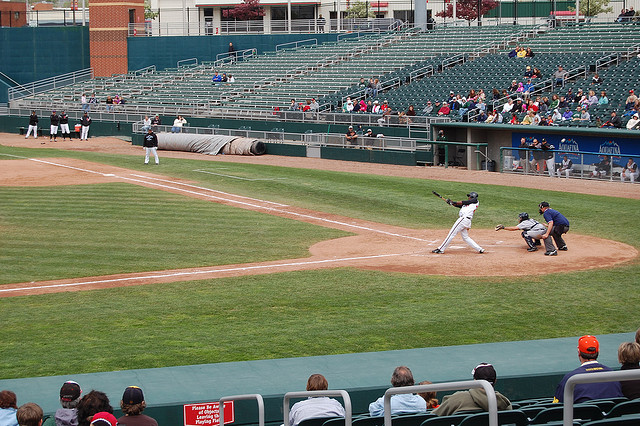What is happening in the image right now? The image shows a live baseball game in progress. A batter is at the plate, apparently just having swung at a pitch. The catcher and the umpire are positioned behind the home plate, while some spectators are in the stands observing the game. Can you describe the roles of different players on the baseball field? Sure! In a baseball game, players have specific positions with distinct roles:

1. **Pitcher**: Throws the baseball from the pitcher's mound to the catcher.
2. **Catcher**: Catches pitches that the batter doesn't hit, fields bunts and throws to prevent stolen bases.
3. **First Baseman**: Fields balls hit near first base and receives throws from other infielders to get runners out.
4. **Second Baseman**: Fields balls hit near second base and often collaborates with the shortstop to turn double plays.
5. **Shortstop**: Fields balls hit between second and third base and collaborates with the second baseman on double plays.
6. **Third Baseman**: Fields balls hit near third base, often needs quick reflexes due to hard-hit balls.
7. **Left Fielder**: Covers the left portion of the outfield, catches fly balls, and fields balls hit deep in the left field.
8. **Center Fielder**: Covers the middle portion of the outfield, often the fastest of the outfielders.
9. **Right Fielder**: Covers the right portion of the outfield, fields balls hit deep to right and typically has a strong throwing arm.

These roles are crucial for both defense and strategic gameplay. 